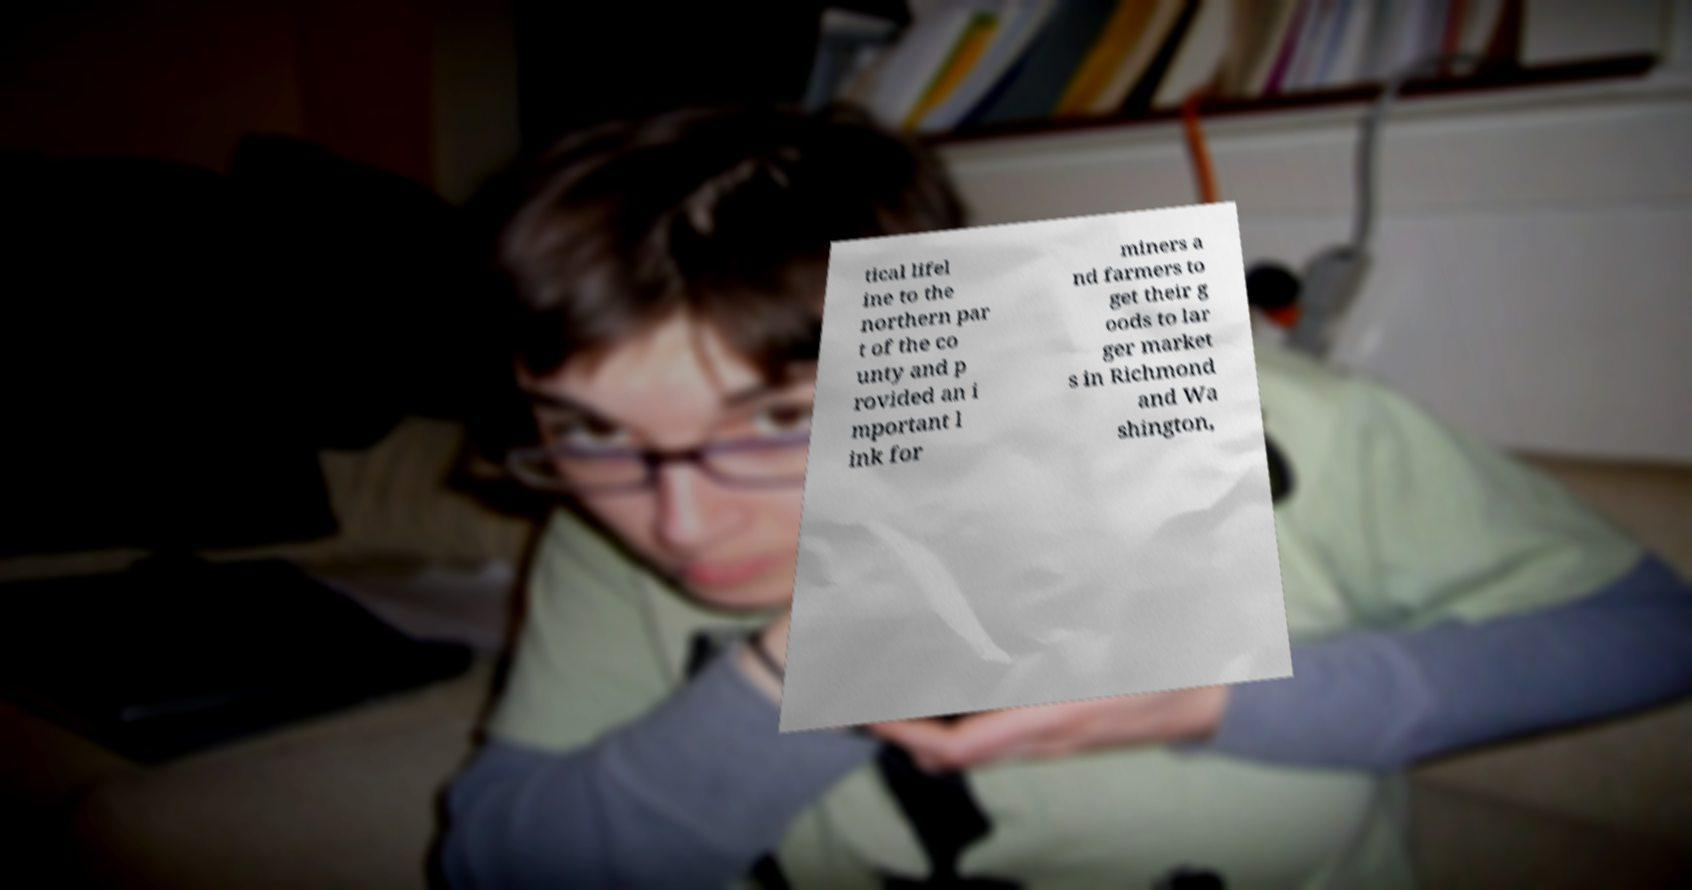Please identify and transcribe the text found in this image. tical lifel ine to the northern par t of the co unty and p rovided an i mportant l ink for miners a nd farmers to get their g oods to lar ger market s in Richmond and Wa shington, 